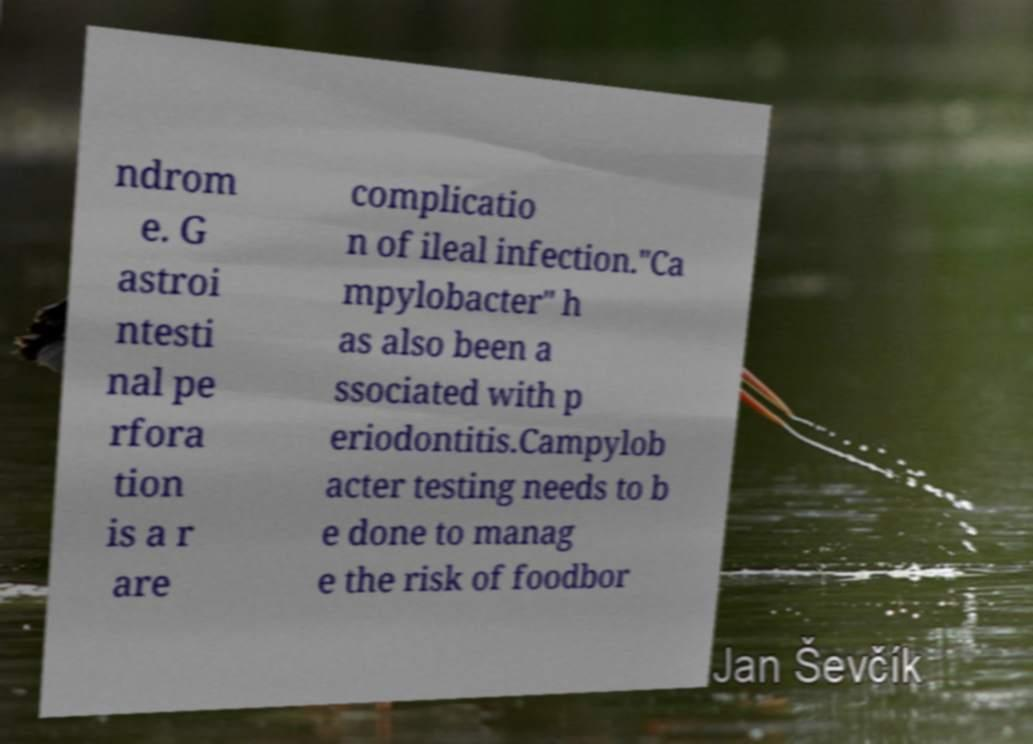Could you assist in decoding the text presented in this image and type it out clearly? ndrom e. G astroi ntesti nal pe rfora tion is a r are complicatio n of ileal infection."Ca mpylobacter" h as also been a ssociated with p eriodontitis.Campylob acter testing needs to b e done to manag e the risk of foodbor 